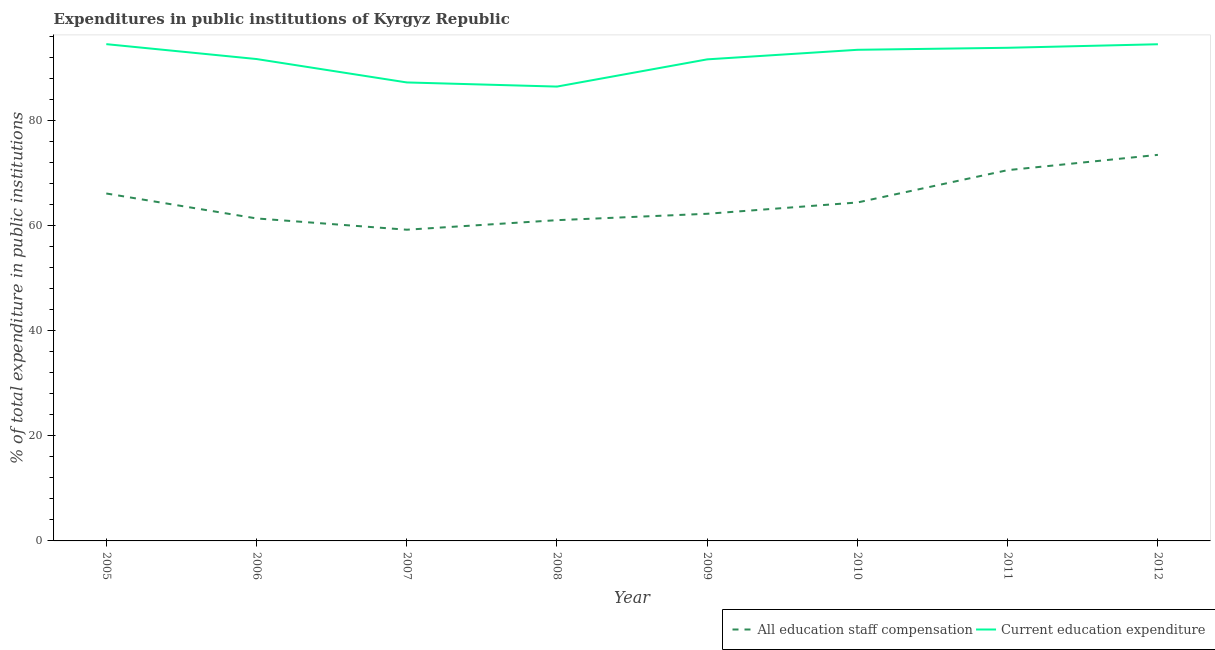How many different coloured lines are there?
Your answer should be very brief. 2. What is the expenditure in staff compensation in 2005?
Give a very brief answer. 66.17. Across all years, what is the maximum expenditure in staff compensation?
Make the answer very short. 73.53. Across all years, what is the minimum expenditure in education?
Offer a terse response. 86.53. In which year was the expenditure in education maximum?
Give a very brief answer. 2005. What is the total expenditure in education in the graph?
Your response must be concise. 733.98. What is the difference between the expenditure in staff compensation in 2006 and that in 2009?
Give a very brief answer. -0.89. What is the difference between the expenditure in staff compensation in 2012 and the expenditure in education in 2009?
Provide a short and direct response. -18.19. What is the average expenditure in staff compensation per year?
Keep it short and to the point. 64.86. In the year 2010, what is the difference between the expenditure in staff compensation and expenditure in education?
Provide a short and direct response. -29.08. In how many years, is the expenditure in education greater than 52 %?
Your response must be concise. 8. What is the ratio of the expenditure in staff compensation in 2010 to that in 2011?
Your response must be concise. 0.91. Is the expenditure in education in 2007 less than that in 2010?
Ensure brevity in your answer.  Yes. Is the difference between the expenditure in education in 2005 and 2008 greater than the difference between the expenditure in staff compensation in 2005 and 2008?
Offer a very short reply. Yes. What is the difference between the highest and the second highest expenditure in staff compensation?
Your response must be concise. 2.91. What is the difference between the highest and the lowest expenditure in staff compensation?
Offer a terse response. 14.26. In how many years, is the expenditure in education greater than the average expenditure in education taken over all years?
Provide a succinct answer. 5. Does the expenditure in education monotonically increase over the years?
Provide a succinct answer. No. How many lines are there?
Make the answer very short. 2. Does the graph contain any zero values?
Provide a succinct answer. No. Does the graph contain grids?
Your response must be concise. No. Where does the legend appear in the graph?
Make the answer very short. Bottom right. How many legend labels are there?
Your response must be concise. 2. How are the legend labels stacked?
Provide a succinct answer. Horizontal. What is the title of the graph?
Provide a succinct answer. Expenditures in public institutions of Kyrgyz Republic. What is the label or title of the X-axis?
Make the answer very short. Year. What is the label or title of the Y-axis?
Keep it short and to the point. % of total expenditure in public institutions. What is the % of total expenditure in public institutions in All education staff compensation in 2005?
Your answer should be very brief. 66.17. What is the % of total expenditure in public institutions in Current education expenditure in 2005?
Your answer should be very brief. 94.61. What is the % of total expenditure in public institutions of All education staff compensation in 2006?
Keep it short and to the point. 61.42. What is the % of total expenditure in public institutions in Current education expenditure in 2006?
Make the answer very short. 91.77. What is the % of total expenditure in public institutions of All education staff compensation in 2007?
Your answer should be very brief. 59.27. What is the % of total expenditure in public institutions in Current education expenditure in 2007?
Provide a short and direct response. 87.32. What is the % of total expenditure in public institutions in All education staff compensation in 2008?
Provide a succinct answer. 61.09. What is the % of total expenditure in public institutions in Current education expenditure in 2008?
Your answer should be compact. 86.53. What is the % of total expenditure in public institutions in All education staff compensation in 2009?
Your answer should be compact. 62.3. What is the % of total expenditure in public institutions of Current education expenditure in 2009?
Keep it short and to the point. 91.71. What is the % of total expenditure in public institutions of All education staff compensation in 2010?
Your response must be concise. 64.46. What is the % of total expenditure in public institutions of Current education expenditure in 2010?
Your answer should be very brief. 93.53. What is the % of total expenditure in public institutions in All education staff compensation in 2011?
Ensure brevity in your answer.  70.61. What is the % of total expenditure in public institutions of Current education expenditure in 2011?
Provide a short and direct response. 93.92. What is the % of total expenditure in public institutions in All education staff compensation in 2012?
Offer a terse response. 73.53. What is the % of total expenditure in public institutions in Current education expenditure in 2012?
Offer a terse response. 94.59. Across all years, what is the maximum % of total expenditure in public institutions of All education staff compensation?
Give a very brief answer. 73.53. Across all years, what is the maximum % of total expenditure in public institutions of Current education expenditure?
Give a very brief answer. 94.61. Across all years, what is the minimum % of total expenditure in public institutions in All education staff compensation?
Offer a terse response. 59.27. Across all years, what is the minimum % of total expenditure in public institutions in Current education expenditure?
Your answer should be very brief. 86.53. What is the total % of total expenditure in public institutions of All education staff compensation in the graph?
Make the answer very short. 518.84. What is the total % of total expenditure in public institutions in Current education expenditure in the graph?
Give a very brief answer. 733.98. What is the difference between the % of total expenditure in public institutions of All education staff compensation in 2005 and that in 2006?
Provide a succinct answer. 4.75. What is the difference between the % of total expenditure in public institutions in Current education expenditure in 2005 and that in 2006?
Offer a very short reply. 2.83. What is the difference between the % of total expenditure in public institutions of All education staff compensation in 2005 and that in 2007?
Your answer should be compact. 6.9. What is the difference between the % of total expenditure in public institutions of Current education expenditure in 2005 and that in 2007?
Give a very brief answer. 7.29. What is the difference between the % of total expenditure in public institutions in All education staff compensation in 2005 and that in 2008?
Ensure brevity in your answer.  5.08. What is the difference between the % of total expenditure in public institutions of Current education expenditure in 2005 and that in 2008?
Your answer should be very brief. 8.08. What is the difference between the % of total expenditure in public institutions of All education staff compensation in 2005 and that in 2009?
Provide a succinct answer. 3.86. What is the difference between the % of total expenditure in public institutions in Current education expenditure in 2005 and that in 2009?
Provide a succinct answer. 2.9. What is the difference between the % of total expenditure in public institutions in All education staff compensation in 2005 and that in 2010?
Keep it short and to the point. 1.71. What is the difference between the % of total expenditure in public institutions in Current education expenditure in 2005 and that in 2010?
Ensure brevity in your answer.  1.07. What is the difference between the % of total expenditure in public institutions of All education staff compensation in 2005 and that in 2011?
Keep it short and to the point. -4.45. What is the difference between the % of total expenditure in public institutions in Current education expenditure in 2005 and that in 2011?
Ensure brevity in your answer.  0.69. What is the difference between the % of total expenditure in public institutions of All education staff compensation in 2005 and that in 2012?
Offer a terse response. -7.36. What is the difference between the % of total expenditure in public institutions in Current education expenditure in 2005 and that in 2012?
Give a very brief answer. 0.02. What is the difference between the % of total expenditure in public institutions in All education staff compensation in 2006 and that in 2007?
Your response must be concise. 2.15. What is the difference between the % of total expenditure in public institutions of Current education expenditure in 2006 and that in 2007?
Your response must be concise. 4.46. What is the difference between the % of total expenditure in public institutions in All education staff compensation in 2006 and that in 2008?
Provide a short and direct response. 0.33. What is the difference between the % of total expenditure in public institutions of Current education expenditure in 2006 and that in 2008?
Ensure brevity in your answer.  5.25. What is the difference between the % of total expenditure in public institutions in All education staff compensation in 2006 and that in 2009?
Offer a very short reply. -0.89. What is the difference between the % of total expenditure in public institutions in Current education expenditure in 2006 and that in 2009?
Provide a succinct answer. 0.06. What is the difference between the % of total expenditure in public institutions of All education staff compensation in 2006 and that in 2010?
Offer a terse response. -3.04. What is the difference between the % of total expenditure in public institutions in Current education expenditure in 2006 and that in 2010?
Give a very brief answer. -1.76. What is the difference between the % of total expenditure in public institutions in All education staff compensation in 2006 and that in 2011?
Make the answer very short. -9.2. What is the difference between the % of total expenditure in public institutions in Current education expenditure in 2006 and that in 2011?
Your response must be concise. -2.14. What is the difference between the % of total expenditure in public institutions of All education staff compensation in 2006 and that in 2012?
Make the answer very short. -12.11. What is the difference between the % of total expenditure in public institutions of Current education expenditure in 2006 and that in 2012?
Offer a terse response. -2.82. What is the difference between the % of total expenditure in public institutions of All education staff compensation in 2007 and that in 2008?
Your response must be concise. -1.82. What is the difference between the % of total expenditure in public institutions of Current education expenditure in 2007 and that in 2008?
Give a very brief answer. 0.79. What is the difference between the % of total expenditure in public institutions in All education staff compensation in 2007 and that in 2009?
Ensure brevity in your answer.  -3.04. What is the difference between the % of total expenditure in public institutions of Current education expenditure in 2007 and that in 2009?
Provide a short and direct response. -4.39. What is the difference between the % of total expenditure in public institutions of All education staff compensation in 2007 and that in 2010?
Your answer should be compact. -5.19. What is the difference between the % of total expenditure in public institutions in Current education expenditure in 2007 and that in 2010?
Ensure brevity in your answer.  -6.22. What is the difference between the % of total expenditure in public institutions of All education staff compensation in 2007 and that in 2011?
Make the answer very short. -11.34. What is the difference between the % of total expenditure in public institutions in Current education expenditure in 2007 and that in 2011?
Give a very brief answer. -6.6. What is the difference between the % of total expenditure in public institutions of All education staff compensation in 2007 and that in 2012?
Give a very brief answer. -14.26. What is the difference between the % of total expenditure in public institutions in Current education expenditure in 2007 and that in 2012?
Ensure brevity in your answer.  -7.27. What is the difference between the % of total expenditure in public institutions in All education staff compensation in 2008 and that in 2009?
Provide a succinct answer. -1.22. What is the difference between the % of total expenditure in public institutions in Current education expenditure in 2008 and that in 2009?
Your response must be concise. -5.18. What is the difference between the % of total expenditure in public institutions of All education staff compensation in 2008 and that in 2010?
Provide a short and direct response. -3.37. What is the difference between the % of total expenditure in public institutions of Current education expenditure in 2008 and that in 2010?
Provide a short and direct response. -7.01. What is the difference between the % of total expenditure in public institutions of All education staff compensation in 2008 and that in 2011?
Make the answer very short. -9.53. What is the difference between the % of total expenditure in public institutions in Current education expenditure in 2008 and that in 2011?
Provide a succinct answer. -7.39. What is the difference between the % of total expenditure in public institutions of All education staff compensation in 2008 and that in 2012?
Your answer should be compact. -12.44. What is the difference between the % of total expenditure in public institutions in Current education expenditure in 2008 and that in 2012?
Your answer should be compact. -8.06. What is the difference between the % of total expenditure in public institutions in All education staff compensation in 2009 and that in 2010?
Your answer should be compact. -2.15. What is the difference between the % of total expenditure in public institutions of Current education expenditure in 2009 and that in 2010?
Offer a terse response. -1.82. What is the difference between the % of total expenditure in public institutions in All education staff compensation in 2009 and that in 2011?
Provide a short and direct response. -8.31. What is the difference between the % of total expenditure in public institutions in Current education expenditure in 2009 and that in 2011?
Ensure brevity in your answer.  -2.2. What is the difference between the % of total expenditure in public institutions of All education staff compensation in 2009 and that in 2012?
Offer a very short reply. -11.22. What is the difference between the % of total expenditure in public institutions in Current education expenditure in 2009 and that in 2012?
Offer a very short reply. -2.88. What is the difference between the % of total expenditure in public institutions in All education staff compensation in 2010 and that in 2011?
Your response must be concise. -6.16. What is the difference between the % of total expenditure in public institutions of Current education expenditure in 2010 and that in 2011?
Make the answer very short. -0.38. What is the difference between the % of total expenditure in public institutions of All education staff compensation in 2010 and that in 2012?
Offer a terse response. -9.07. What is the difference between the % of total expenditure in public institutions in Current education expenditure in 2010 and that in 2012?
Keep it short and to the point. -1.06. What is the difference between the % of total expenditure in public institutions of All education staff compensation in 2011 and that in 2012?
Offer a terse response. -2.91. What is the difference between the % of total expenditure in public institutions in Current education expenditure in 2011 and that in 2012?
Ensure brevity in your answer.  -0.67. What is the difference between the % of total expenditure in public institutions of All education staff compensation in 2005 and the % of total expenditure in public institutions of Current education expenditure in 2006?
Your answer should be compact. -25.61. What is the difference between the % of total expenditure in public institutions of All education staff compensation in 2005 and the % of total expenditure in public institutions of Current education expenditure in 2007?
Your answer should be very brief. -21.15. What is the difference between the % of total expenditure in public institutions in All education staff compensation in 2005 and the % of total expenditure in public institutions in Current education expenditure in 2008?
Keep it short and to the point. -20.36. What is the difference between the % of total expenditure in public institutions in All education staff compensation in 2005 and the % of total expenditure in public institutions in Current education expenditure in 2009?
Keep it short and to the point. -25.55. What is the difference between the % of total expenditure in public institutions in All education staff compensation in 2005 and the % of total expenditure in public institutions in Current education expenditure in 2010?
Keep it short and to the point. -27.37. What is the difference between the % of total expenditure in public institutions in All education staff compensation in 2005 and the % of total expenditure in public institutions in Current education expenditure in 2011?
Your answer should be very brief. -27.75. What is the difference between the % of total expenditure in public institutions in All education staff compensation in 2005 and the % of total expenditure in public institutions in Current education expenditure in 2012?
Keep it short and to the point. -28.42. What is the difference between the % of total expenditure in public institutions of All education staff compensation in 2006 and the % of total expenditure in public institutions of Current education expenditure in 2007?
Your response must be concise. -25.9. What is the difference between the % of total expenditure in public institutions of All education staff compensation in 2006 and the % of total expenditure in public institutions of Current education expenditure in 2008?
Offer a terse response. -25.11. What is the difference between the % of total expenditure in public institutions of All education staff compensation in 2006 and the % of total expenditure in public institutions of Current education expenditure in 2009?
Keep it short and to the point. -30.3. What is the difference between the % of total expenditure in public institutions of All education staff compensation in 2006 and the % of total expenditure in public institutions of Current education expenditure in 2010?
Provide a succinct answer. -32.12. What is the difference between the % of total expenditure in public institutions of All education staff compensation in 2006 and the % of total expenditure in public institutions of Current education expenditure in 2011?
Provide a succinct answer. -32.5. What is the difference between the % of total expenditure in public institutions of All education staff compensation in 2006 and the % of total expenditure in public institutions of Current education expenditure in 2012?
Provide a succinct answer. -33.17. What is the difference between the % of total expenditure in public institutions in All education staff compensation in 2007 and the % of total expenditure in public institutions in Current education expenditure in 2008?
Give a very brief answer. -27.26. What is the difference between the % of total expenditure in public institutions of All education staff compensation in 2007 and the % of total expenditure in public institutions of Current education expenditure in 2009?
Give a very brief answer. -32.44. What is the difference between the % of total expenditure in public institutions of All education staff compensation in 2007 and the % of total expenditure in public institutions of Current education expenditure in 2010?
Give a very brief answer. -34.26. What is the difference between the % of total expenditure in public institutions in All education staff compensation in 2007 and the % of total expenditure in public institutions in Current education expenditure in 2011?
Keep it short and to the point. -34.65. What is the difference between the % of total expenditure in public institutions of All education staff compensation in 2007 and the % of total expenditure in public institutions of Current education expenditure in 2012?
Provide a succinct answer. -35.32. What is the difference between the % of total expenditure in public institutions of All education staff compensation in 2008 and the % of total expenditure in public institutions of Current education expenditure in 2009?
Provide a succinct answer. -30.63. What is the difference between the % of total expenditure in public institutions of All education staff compensation in 2008 and the % of total expenditure in public institutions of Current education expenditure in 2010?
Offer a terse response. -32.45. What is the difference between the % of total expenditure in public institutions in All education staff compensation in 2008 and the % of total expenditure in public institutions in Current education expenditure in 2011?
Your answer should be very brief. -32.83. What is the difference between the % of total expenditure in public institutions in All education staff compensation in 2008 and the % of total expenditure in public institutions in Current education expenditure in 2012?
Offer a very short reply. -33.5. What is the difference between the % of total expenditure in public institutions of All education staff compensation in 2009 and the % of total expenditure in public institutions of Current education expenditure in 2010?
Give a very brief answer. -31.23. What is the difference between the % of total expenditure in public institutions in All education staff compensation in 2009 and the % of total expenditure in public institutions in Current education expenditure in 2011?
Ensure brevity in your answer.  -31.61. What is the difference between the % of total expenditure in public institutions in All education staff compensation in 2009 and the % of total expenditure in public institutions in Current education expenditure in 2012?
Offer a very short reply. -32.29. What is the difference between the % of total expenditure in public institutions of All education staff compensation in 2010 and the % of total expenditure in public institutions of Current education expenditure in 2011?
Keep it short and to the point. -29.46. What is the difference between the % of total expenditure in public institutions of All education staff compensation in 2010 and the % of total expenditure in public institutions of Current education expenditure in 2012?
Your answer should be compact. -30.13. What is the difference between the % of total expenditure in public institutions of All education staff compensation in 2011 and the % of total expenditure in public institutions of Current education expenditure in 2012?
Make the answer very short. -23.98. What is the average % of total expenditure in public institutions in All education staff compensation per year?
Your answer should be compact. 64.86. What is the average % of total expenditure in public institutions in Current education expenditure per year?
Offer a terse response. 91.75. In the year 2005, what is the difference between the % of total expenditure in public institutions of All education staff compensation and % of total expenditure in public institutions of Current education expenditure?
Keep it short and to the point. -28.44. In the year 2006, what is the difference between the % of total expenditure in public institutions in All education staff compensation and % of total expenditure in public institutions in Current education expenditure?
Provide a short and direct response. -30.36. In the year 2007, what is the difference between the % of total expenditure in public institutions in All education staff compensation and % of total expenditure in public institutions in Current education expenditure?
Your answer should be very brief. -28.05. In the year 2008, what is the difference between the % of total expenditure in public institutions of All education staff compensation and % of total expenditure in public institutions of Current education expenditure?
Your answer should be compact. -25.44. In the year 2009, what is the difference between the % of total expenditure in public institutions of All education staff compensation and % of total expenditure in public institutions of Current education expenditure?
Keep it short and to the point. -29.41. In the year 2010, what is the difference between the % of total expenditure in public institutions of All education staff compensation and % of total expenditure in public institutions of Current education expenditure?
Your answer should be compact. -29.08. In the year 2011, what is the difference between the % of total expenditure in public institutions in All education staff compensation and % of total expenditure in public institutions in Current education expenditure?
Your response must be concise. -23.3. In the year 2012, what is the difference between the % of total expenditure in public institutions of All education staff compensation and % of total expenditure in public institutions of Current education expenditure?
Give a very brief answer. -21.06. What is the ratio of the % of total expenditure in public institutions in All education staff compensation in 2005 to that in 2006?
Ensure brevity in your answer.  1.08. What is the ratio of the % of total expenditure in public institutions of Current education expenditure in 2005 to that in 2006?
Give a very brief answer. 1.03. What is the ratio of the % of total expenditure in public institutions of All education staff compensation in 2005 to that in 2007?
Give a very brief answer. 1.12. What is the ratio of the % of total expenditure in public institutions in Current education expenditure in 2005 to that in 2007?
Provide a short and direct response. 1.08. What is the ratio of the % of total expenditure in public institutions in All education staff compensation in 2005 to that in 2008?
Your answer should be very brief. 1.08. What is the ratio of the % of total expenditure in public institutions of Current education expenditure in 2005 to that in 2008?
Provide a succinct answer. 1.09. What is the ratio of the % of total expenditure in public institutions of All education staff compensation in 2005 to that in 2009?
Provide a short and direct response. 1.06. What is the ratio of the % of total expenditure in public institutions in Current education expenditure in 2005 to that in 2009?
Your answer should be compact. 1.03. What is the ratio of the % of total expenditure in public institutions of All education staff compensation in 2005 to that in 2010?
Provide a succinct answer. 1.03. What is the ratio of the % of total expenditure in public institutions of Current education expenditure in 2005 to that in 2010?
Ensure brevity in your answer.  1.01. What is the ratio of the % of total expenditure in public institutions of All education staff compensation in 2005 to that in 2011?
Offer a very short reply. 0.94. What is the ratio of the % of total expenditure in public institutions of Current education expenditure in 2005 to that in 2011?
Provide a succinct answer. 1.01. What is the ratio of the % of total expenditure in public institutions in All education staff compensation in 2005 to that in 2012?
Your answer should be compact. 0.9. What is the ratio of the % of total expenditure in public institutions in All education staff compensation in 2006 to that in 2007?
Keep it short and to the point. 1.04. What is the ratio of the % of total expenditure in public institutions of Current education expenditure in 2006 to that in 2007?
Provide a succinct answer. 1.05. What is the ratio of the % of total expenditure in public institutions in All education staff compensation in 2006 to that in 2008?
Provide a short and direct response. 1.01. What is the ratio of the % of total expenditure in public institutions of Current education expenditure in 2006 to that in 2008?
Your answer should be compact. 1.06. What is the ratio of the % of total expenditure in public institutions in All education staff compensation in 2006 to that in 2009?
Give a very brief answer. 0.99. What is the ratio of the % of total expenditure in public institutions of All education staff compensation in 2006 to that in 2010?
Offer a very short reply. 0.95. What is the ratio of the % of total expenditure in public institutions in Current education expenditure in 2006 to that in 2010?
Your answer should be compact. 0.98. What is the ratio of the % of total expenditure in public institutions of All education staff compensation in 2006 to that in 2011?
Your answer should be very brief. 0.87. What is the ratio of the % of total expenditure in public institutions in Current education expenditure in 2006 to that in 2011?
Your response must be concise. 0.98. What is the ratio of the % of total expenditure in public institutions of All education staff compensation in 2006 to that in 2012?
Give a very brief answer. 0.84. What is the ratio of the % of total expenditure in public institutions of Current education expenditure in 2006 to that in 2012?
Keep it short and to the point. 0.97. What is the ratio of the % of total expenditure in public institutions in All education staff compensation in 2007 to that in 2008?
Your answer should be very brief. 0.97. What is the ratio of the % of total expenditure in public institutions in Current education expenditure in 2007 to that in 2008?
Keep it short and to the point. 1.01. What is the ratio of the % of total expenditure in public institutions of All education staff compensation in 2007 to that in 2009?
Ensure brevity in your answer.  0.95. What is the ratio of the % of total expenditure in public institutions of Current education expenditure in 2007 to that in 2009?
Make the answer very short. 0.95. What is the ratio of the % of total expenditure in public institutions of All education staff compensation in 2007 to that in 2010?
Your response must be concise. 0.92. What is the ratio of the % of total expenditure in public institutions of Current education expenditure in 2007 to that in 2010?
Keep it short and to the point. 0.93. What is the ratio of the % of total expenditure in public institutions of All education staff compensation in 2007 to that in 2011?
Your answer should be compact. 0.84. What is the ratio of the % of total expenditure in public institutions of Current education expenditure in 2007 to that in 2011?
Ensure brevity in your answer.  0.93. What is the ratio of the % of total expenditure in public institutions in All education staff compensation in 2007 to that in 2012?
Keep it short and to the point. 0.81. What is the ratio of the % of total expenditure in public institutions in All education staff compensation in 2008 to that in 2009?
Make the answer very short. 0.98. What is the ratio of the % of total expenditure in public institutions of Current education expenditure in 2008 to that in 2009?
Give a very brief answer. 0.94. What is the ratio of the % of total expenditure in public institutions in All education staff compensation in 2008 to that in 2010?
Make the answer very short. 0.95. What is the ratio of the % of total expenditure in public institutions of Current education expenditure in 2008 to that in 2010?
Provide a short and direct response. 0.93. What is the ratio of the % of total expenditure in public institutions in All education staff compensation in 2008 to that in 2011?
Make the answer very short. 0.87. What is the ratio of the % of total expenditure in public institutions of Current education expenditure in 2008 to that in 2011?
Provide a short and direct response. 0.92. What is the ratio of the % of total expenditure in public institutions of All education staff compensation in 2008 to that in 2012?
Make the answer very short. 0.83. What is the ratio of the % of total expenditure in public institutions in Current education expenditure in 2008 to that in 2012?
Your response must be concise. 0.91. What is the ratio of the % of total expenditure in public institutions in All education staff compensation in 2009 to that in 2010?
Your response must be concise. 0.97. What is the ratio of the % of total expenditure in public institutions of Current education expenditure in 2009 to that in 2010?
Provide a succinct answer. 0.98. What is the ratio of the % of total expenditure in public institutions in All education staff compensation in 2009 to that in 2011?
Provide a short and direct response. 0.88. What is the ratio of the % of total expenditure in public institutions in Current education expenditure in 2009 to that in 2011?
Your answer should be compact. 0.98. What is the ratio of the % of total expenditure in public institutions in All education staff compensation in 2009 to that in 2012?
Offer a terse response. 0.85. What is the ratio of the % of total expenditure in public institutions in Current education expenditure in 2009 to that in 2012?
Your answer should be compact. 0.97. What is the ratio of the % of total expenditure in public institutions in All education staff compensation in 2010 to that in 2011?
Provide a short and direct response. 0.91. What is the ratio of the % of total expenditure in public institutions in Current education expenditure in 2010 to that in 2011?
Make the answer very short. 1. What is the ratio of the % of total expenditure in public institutions of All education staff compensation in 2010 to that in 2012?
Make the answer very short. 0.88. What is the ratio of the % of total expenditure in public institutions of All education staff compensation in 2011 to that in 2012?
Your answer should be very brief. 0.96. What is the difference between the highest and the second highest % of total expenditure in public institutions in All education staff compensation?
Keep it short and to the point. 2.91. What is the difference between the highest and the second highest % of total expenditure in public institutions of Current education expenditure?
Your response must be concise. 0.02. What is the difference between the highest and the lowest % of total expenditure in public institutions in All education staff compensation?
Keep it short and to the point. 14.26. What is the difference between the highest and the lowest % of total expenditure in public institutions of Current education expenditure?
Ensure brevity in your answer.  8.08. 